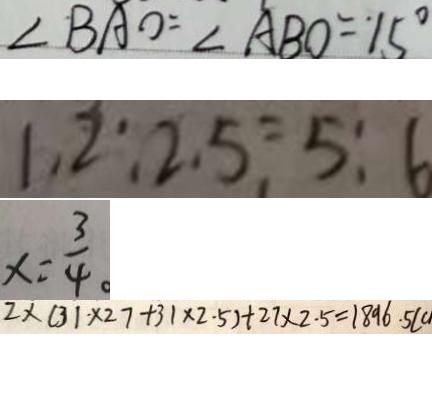Convert formula to latex. <formula><loc_0><loc_0><loc_500><loc_500>\angle B A O = \angle A B O = 1 5 ^ { \circ } 
 1 . 2 : 2 . 5 = 5 : 6 
 x = \frac { 3 } { 4 } 。 
 2 \times ( 3 1 \times 2 7 + 3 1 \times 2 . 5 ) + 2 7 \times 2 . 5 = 1 8 9 6 . 5 ( c</formula> 